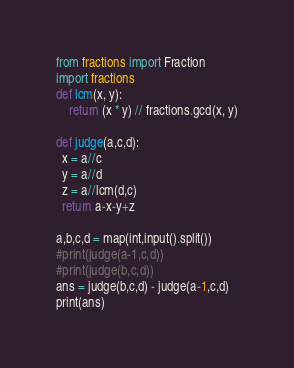<code> <loc_0><loc_0><loc_500><loc_500><_Python_>from fractions import Fraction
import fractions
def lcm(x, y):
    return (x * y) // fractions.gcd(x, y)

def judge(a,c,d):
  x = a//c
  y = a//d
  z = a//lcm(d,c)
  return a-x-y+z

a,b,c,d = map(int,input().split())
#print(judge(a-1,c,d))
#print(judge(b,c,d))
ans = judge(b,c,d) - judge(a-1,c,d)
print(ans)</code> 